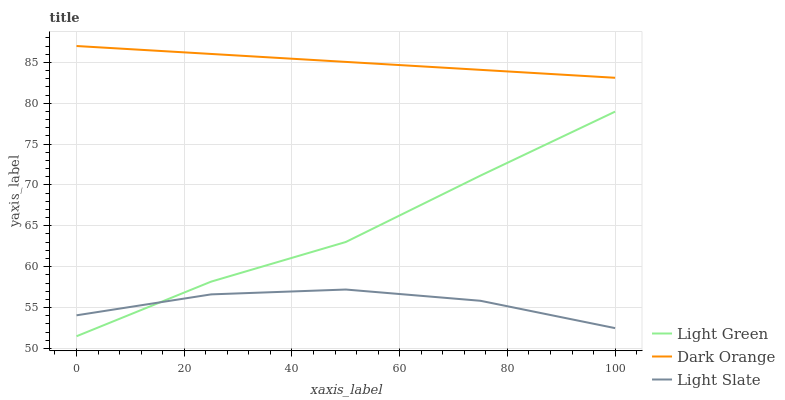Does Light Green have the minimum area under the curve?
Answer yes or no. No. Does Light Green have the maximum area under the curve?
Answer yes or no. No. Is Light Green the smoothest?
Answer yes or no. No. Is Light Green the roughest?
Answer yes or no. No. Does Dark Orange have the lowest value?
Answer yes or no. No. Does Light Green have the highest value?
Answer yes or no. No. Is Light Green less than Dark Orange?
Answer yes or no. Yes. Is Dark Orange greater than Light Slate?
Answer yes or no. Yes. Does Light Green intersect Dark Orange?
Answer yes or no. No. 